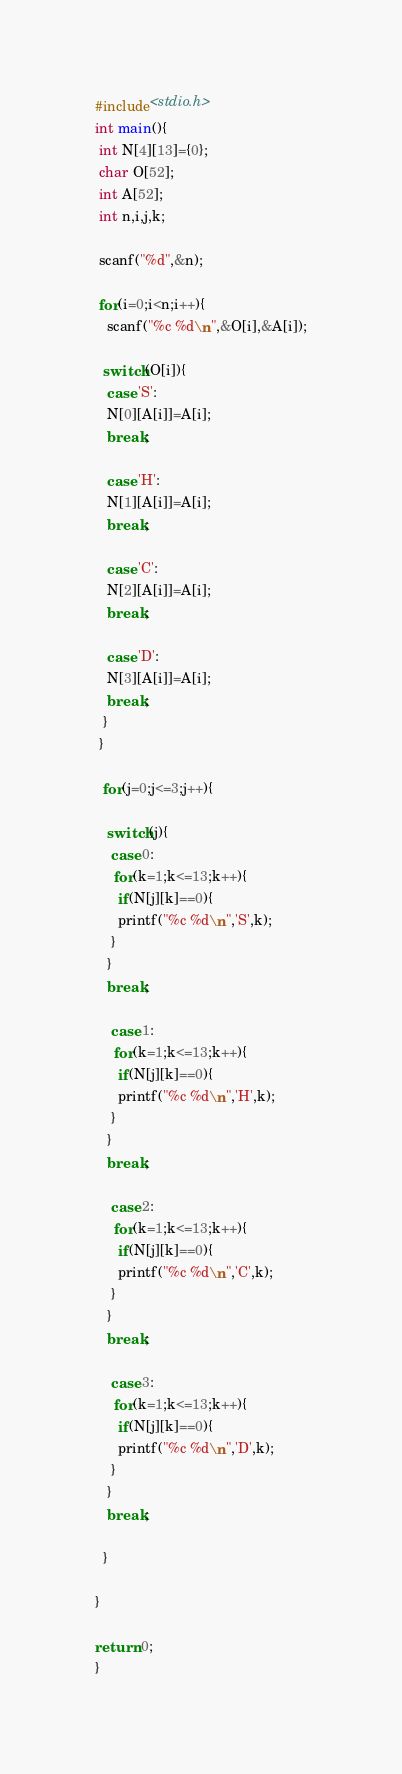<code> <loc_0><loc_0><loc_500><loc_500><_C_>#include<stdio.h>
int main(){
 int N[4][13]={0};
 char O[52];
 int A[52];
 int n,i,j,k;

 scanf("%d",&n);

 for(i=0;i<n;i++){
   scanf("%c %d\n",&O[i],&A[i]);
 
  switch(O[i]){
   case 'S':
   N[0][A[i]]=A[i];
   break;

   case 'H':
   N[1][A[i]]=A[i];
   break;

   case 'C':
   N[2][A[i]]=A[i];
   break;

   case 'D':
   N[3][A[i]]=A[i];
   break;
  }
 }

  for(j=0;j<=3;j++){
  
   switch(j){
    case 0:
     for(k=1;k<=13;k++){
      if(N[j][k]==0){
      printf("%c %d\n",'S',k);
    }
   }
   break;

    case 1:
     for(k=1;k<=13;k++){
      if(N[j][k]==0){
      printf("%c %d\n",'H',k);
    }
   }
   break;

    case 2:
     for(k=1;k<=13;k++){
      if(N[j][k]==0){
      printf("%c %d\n",'C',k);
    }
   }
   break;

    case 3:
     for(k=1;k<=13;k++){
      if(N[j][k]==0){
      printf("%c %d\n",'D',k);
    }
   }
   break;

  }

}

return 0;
}</code> 